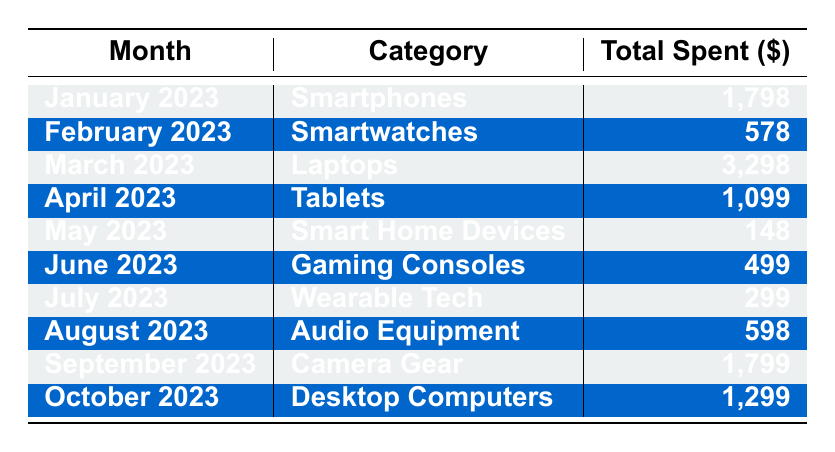What's the total amount spent on smartphones in January 2023? The table shows that in January 2023, the total spent on smartphones is listed as 1,798.
Answer: 1,798 Which month had the highest spending and what was the amount? By reviewing the total spent for each month, March 2023 has the highest spending at 3,298.
Answer: 3,298 How much was spent on smart home devices in May 2023? According to the table, May 2023 has a total spending of 148 on smart home devices.
Answer: 148 Did the spending on tablets in April 2023 exceed 1,000? The table indicates that the spending on tablets in April 2023 is 1,099, which is greater than 1,000.
Answer: Yes What is the average monthly spending on audio equipment and desktops over the two months they are listed? The spending on audio equipment in August is 598, and on desktops in October is 1,299. To find the average, sum these amounts (598 + 1,299 = 1,897) and divide by 2, resulting in 1,897 / 2 = 948.5.
Answer: 948.5 How much was spent altogether on all gadgets from June to August? Reviewing the table, the total spending for June 2023 is 499 (gaming consoles), July 2023 is 299 (wearable tech), and August 2023 is 598 (audio equipment). Adding these amounts: 499 + 299 + 598 = 1,396.
Answer: 1,396 Is there a month where all the purchases were impulse buys? The data states that every item listed in the months shows 'impulse buy' as true. Therefore, every month contains only impulse buys.
Answer: Yes What was the second highest spending category for the year? Analyzing the total spending by categories, February with smartwatches is 578 and April with tablets is 1,099. The category with the second highest total is smartwatches at 578.
Answer: Smartwatches 